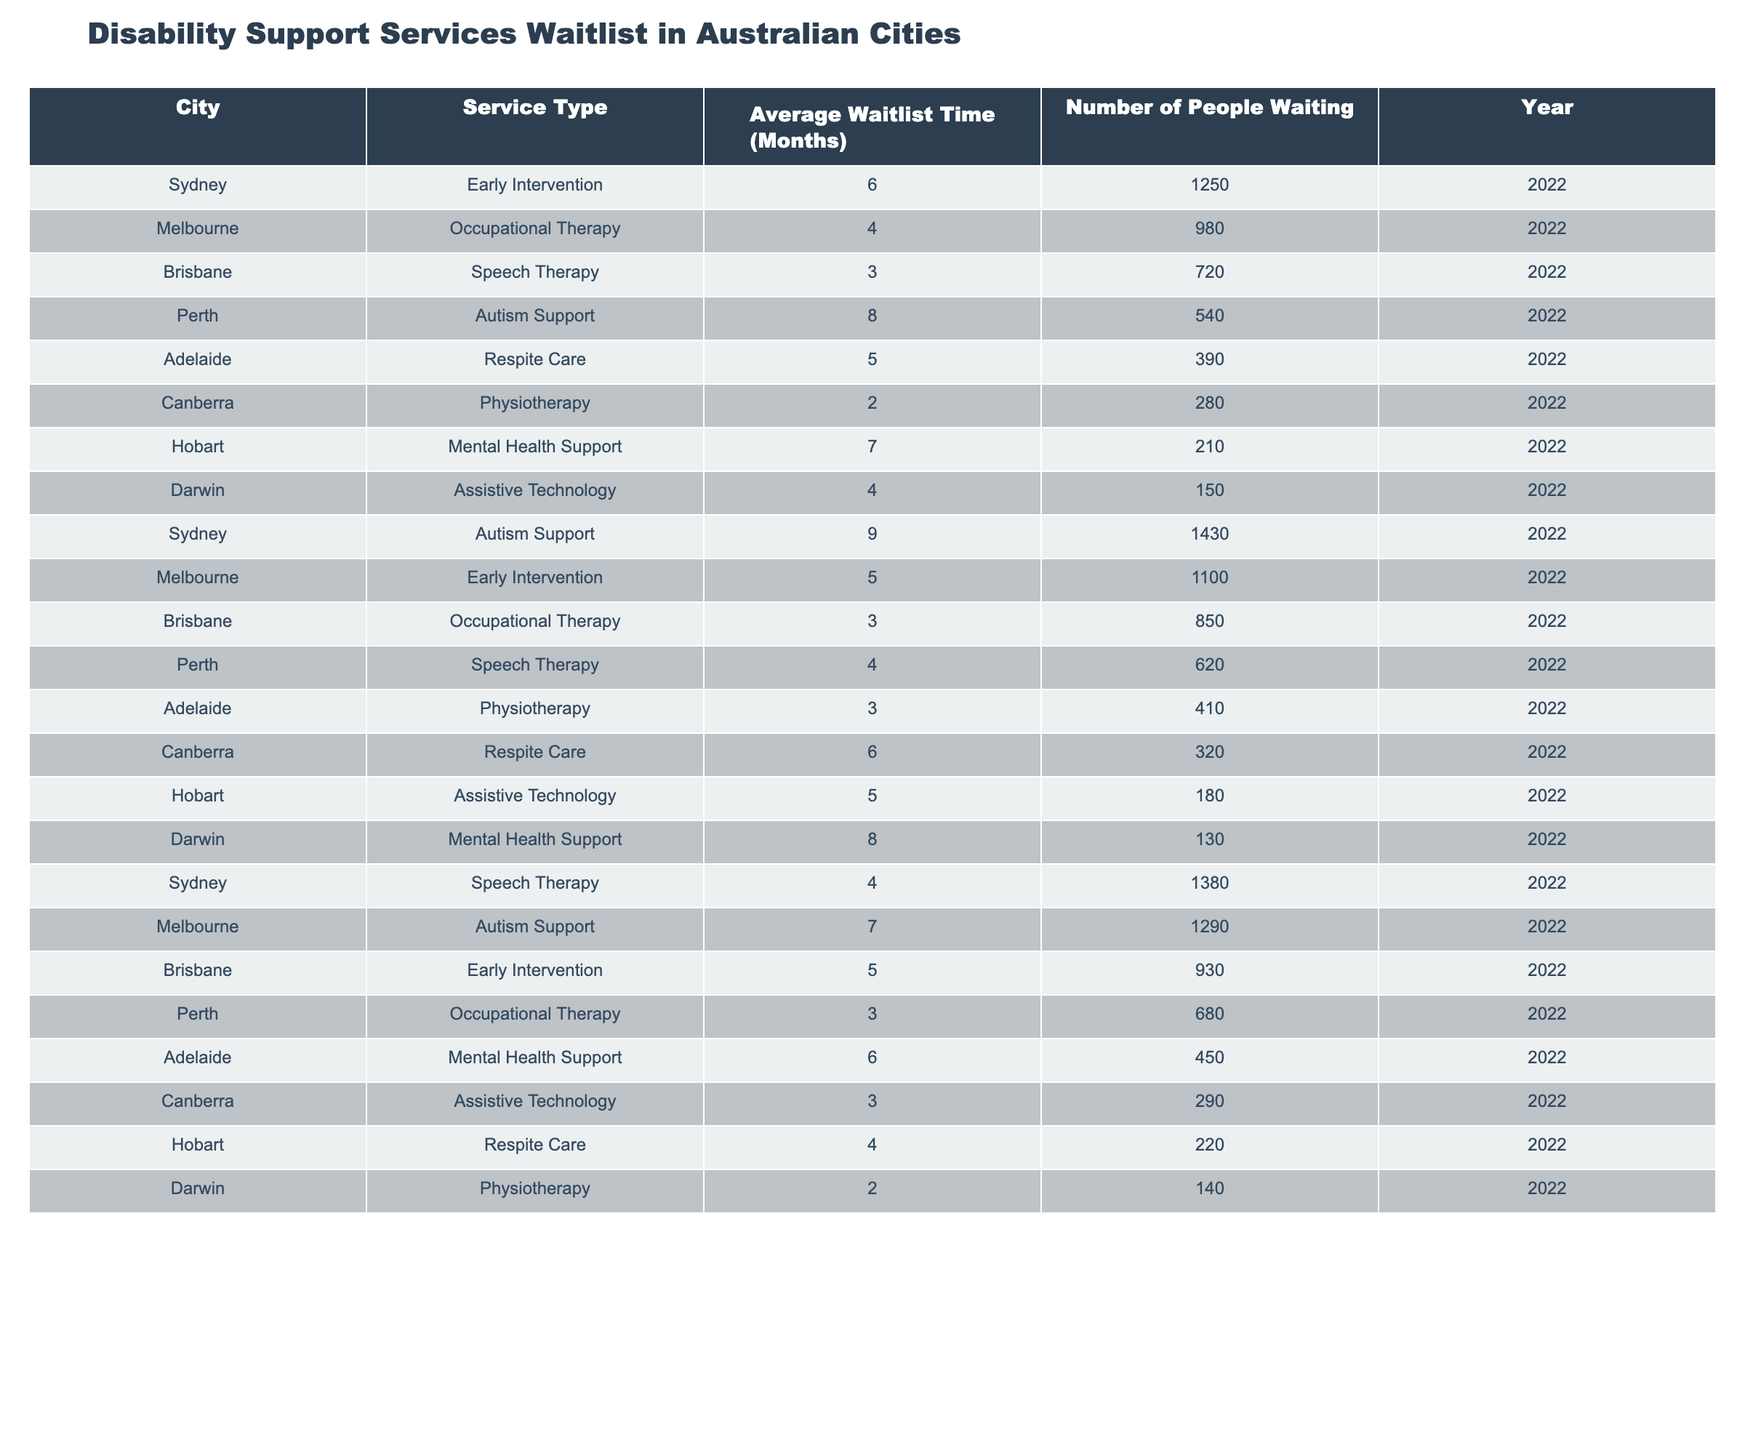What is the average waitlist time for disability support services in Sydney? In Sydney, the average waitlist times for different service types are 6 months (Early Intervention), 9 months (Autism Support), and 4 months (Speech Therapy). To find the average, we sum these values (6 + 9 + 4) = 19 months and divide by the number of service types (3). So, 19/3 = 6.33 months.
Answer: 6.33 Which city has the longest average waitlist time for disability support services? By examining the average waitlist times in the table, Perth has the longest average waitlist time at 8 months for Autism Support.
Answer: Perth Is the waitlist time for Early Intervention services in Brisbane higher than in Melbourne? The waitlist time for Early Intervention services in Brisbane is 5 months, while in Melbourne, it is also 5 months, so they are equal.
Answer: No How many people are waiting for Occupational Therapy services in Melbourne and Perth combined? The number of people waiting for Occupational Therapy services in Melbourne is 980, and in Perth, it is 680. Adding these values together gives us 980 + 680 = 1660 people.
Answer: 1660 What is the total number of people waiting for Speech Therapy services in Sydney and Brisbane? In Sydney, 1380 people are waiting for Speech Therapy services, and in Brisbane, 720 are waiting. Summing these yields 1380 + 720 = 2100 people.
Answer: 2100 Are there more people waiting for Autism Support in Sydney or Melbourne? In Sydney, 1430 people are waiting for Autism Support, while in Melbourne, 1290 are waiting. Comparing these numbers shows that 1430 is greater than 1290.
Answer: Sydney What is the average waitlist time for Respite Care across all the cities listed? The average waitlist times for Respite Care are 5 months in Adelaide and 4 months in Hobart. To find the average, we sum these values (5 + 4) = 9 months and divide by the number of cities (2), which gives us 9/2 = 4.5 months.
Answer: 4.5 Which city has the fewest people waiting for Assistive Technology services? According to the table, Darwin has the fewest people waiting for Assistive Technology services, with 150 individuals on the waitlist.
Answer: Darwin Is there a city where the waitlist time for Physiotherapy is the same as the waitlist time for Respite Care? The waitlist time for Physiotherapy is 3 months in Adelaide and Canberra, while it is 6 months in Canberra for Respite Care. Since they are not equal, the answer is no.
Answer: No What is the difference in average waitlist time for Mental Health Support services between Adelaide and Hobart? In Adelaide, the waitlist time for Mental Health Support is 6 months, and in Hobart, it is 7 months. The difference is calculated as 7 - 6 = 1 month.
Answer: 1 month 